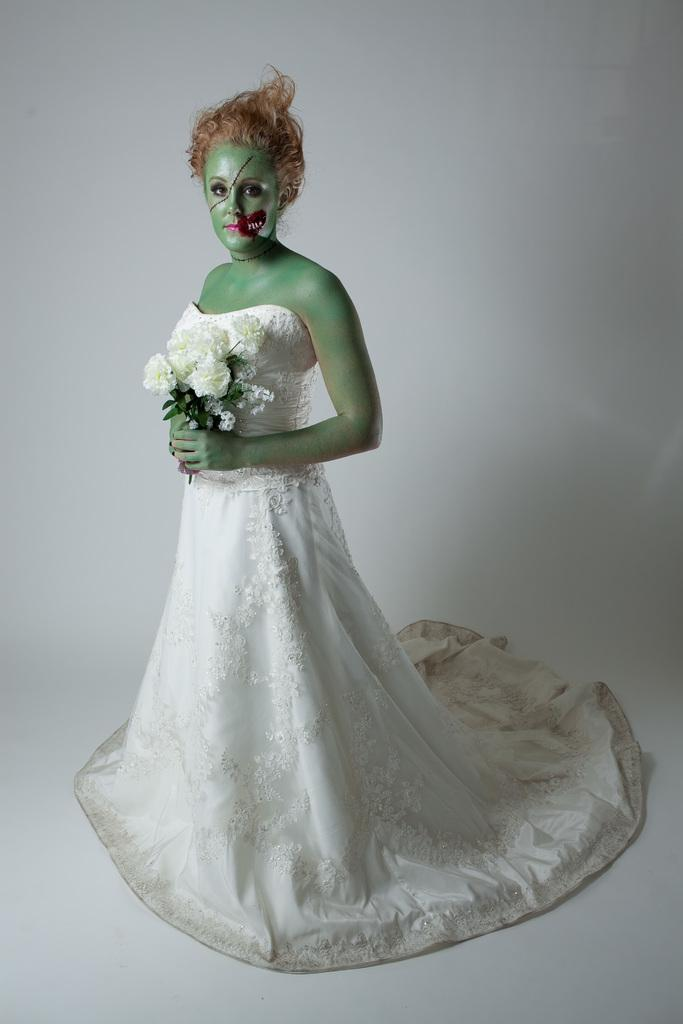What is the color of the wall in the image? There is a white color wall in the image. Who is present in the image? A woman is present in the image. What is the woman wearing? The woman is wearing a white color dress. What is the woman holding in the image? The woman is holding flowers. What type of music is being played on the page in the image? There is no mention of music or a page in the image; it only features a woman standing in front of a white wall holding flowers. 